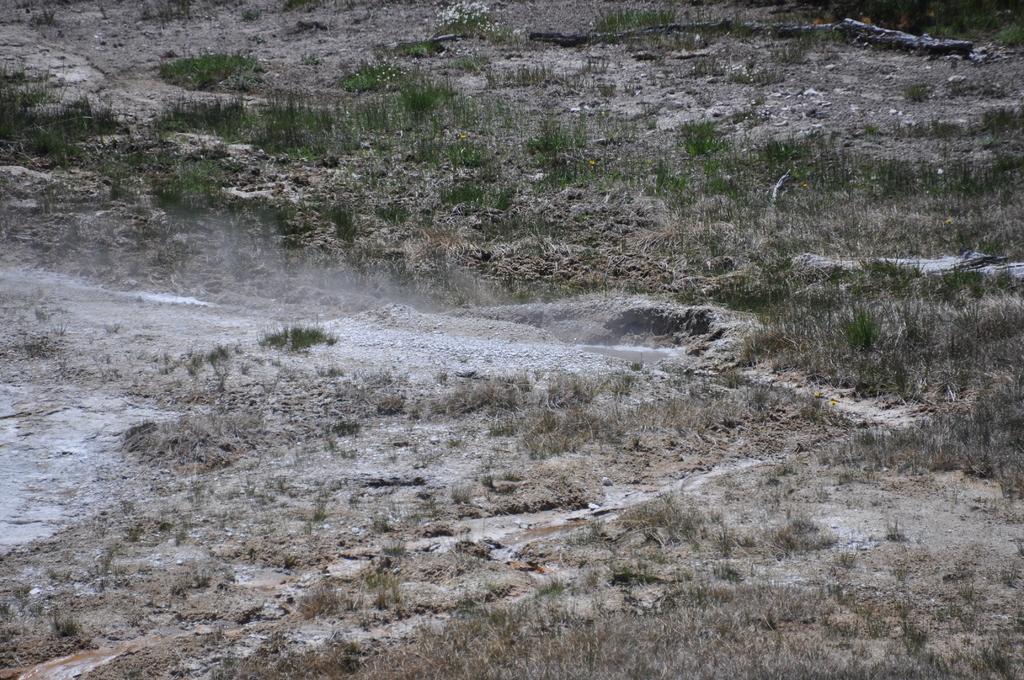Describe this image in one or two sentences. In this image we can see some grass on the land. 